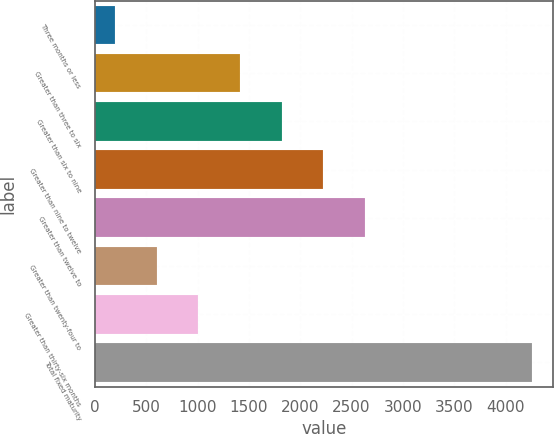Convert chart. <chart><loc_0><loc_0><loc_500><loc_500><bar_chart><fcel>Three months or less<fcel>Greater than three to six<fcel>Greater than six to nine<fcel>Greater than nine to twelve<fcel>Greater than twelve to<fcel>Greater than twenty-four to<fcel>Greater than thirty-six months<fcel>Total fixed maturity<nl><fcel>194.4<fcel>1412.01<fcel>1817.88<fcel>2223.75<fcel>2629.62<fcel>600.27<fcel>1006.14<fcel>4253.1<nl></chart> 